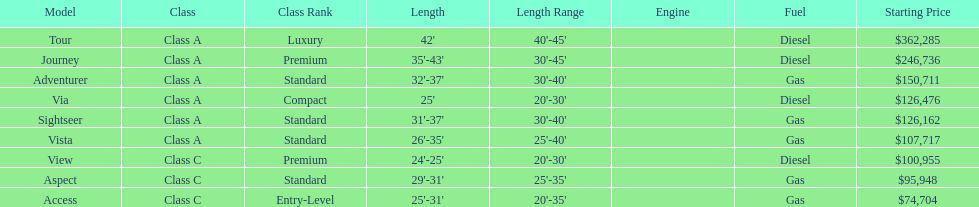Which model is a diesel, the tour or the aspect? Tour. 